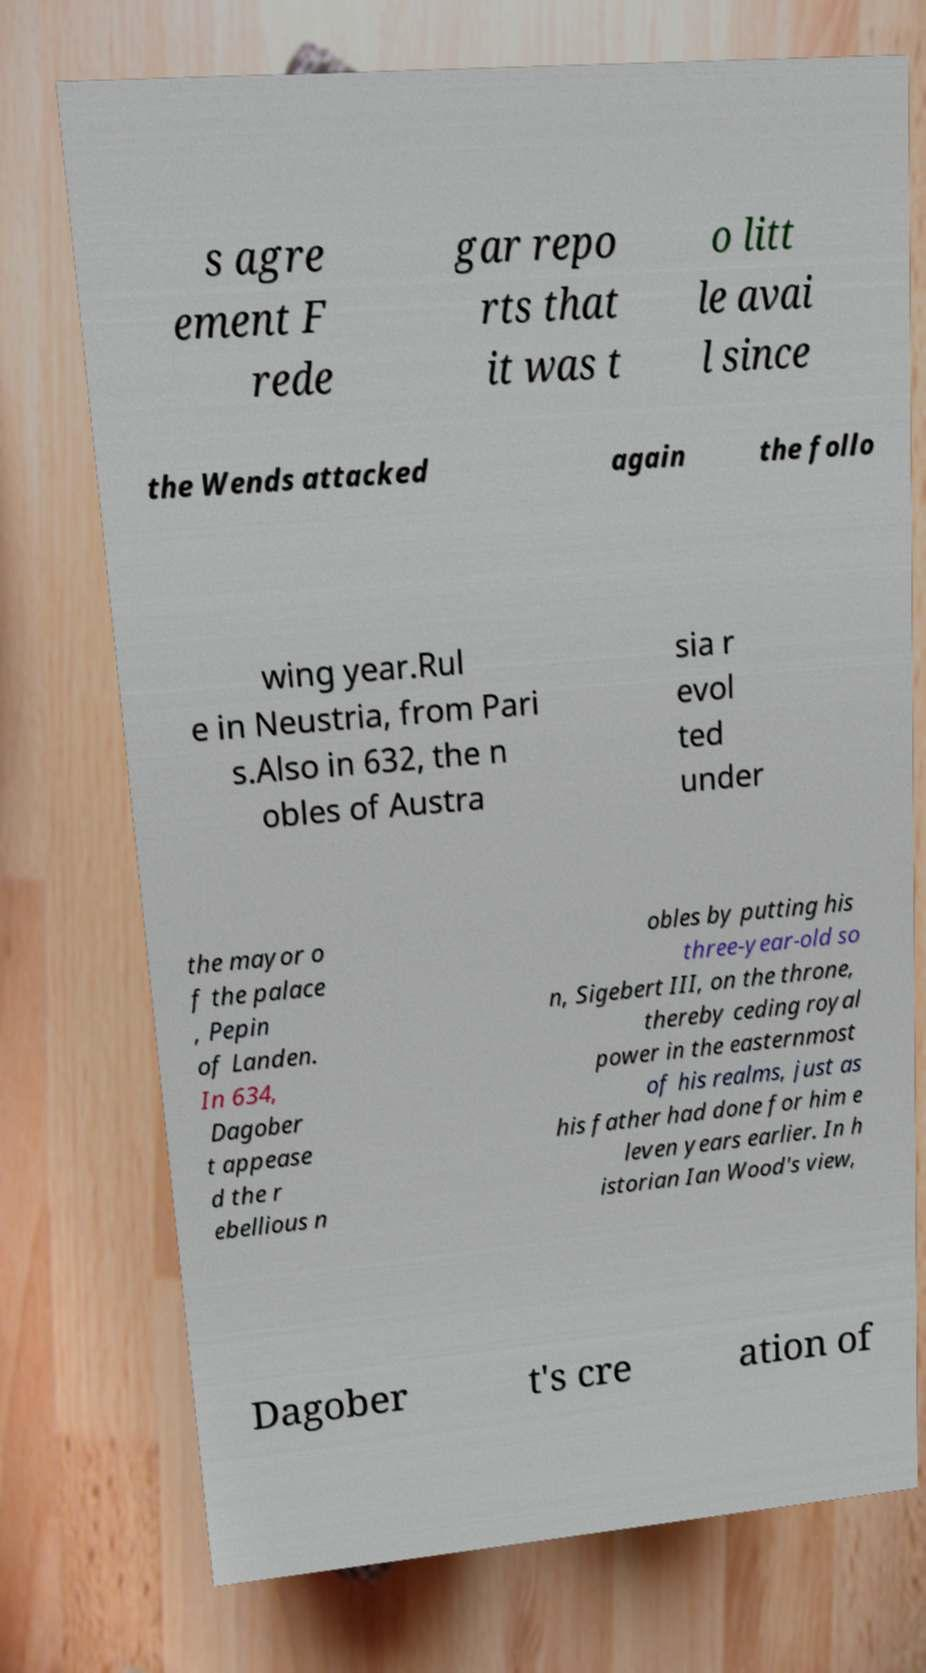Could you assist in decoding the text presented in this image and type it out clearly? s agre ement F rede gar repo rts that it was t o litt le avai l since the Wends attacked again the follo wing year.Rul e in Neustria, from Pari s.Also in 632, the n obles of Austra sia r evol ted under the mayor o f the palace , Pepin of Landen. In 634, Dagober t appease d the r ebellious n obles by putting his three-year-old so n, Sigebert III, on the throne, thereby ceding royal power in the easternmost of his realms, just as his father had done for him e leven years earlier. In h istorian Ian Wood's view, Dagober t's cre ation of 